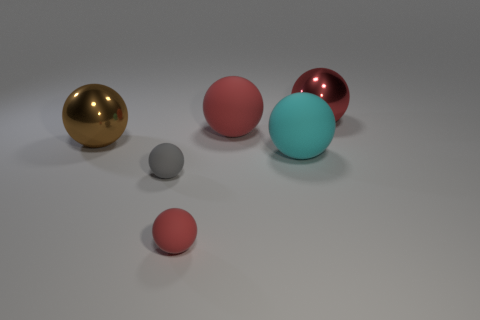How many red spheres must be subtracted to get 1 red spheres? 2 Add 2 yellow cubes. How many objects exist? 8 Subtract all red balls. How many balls are left? 3 Subtract all small gray rubber spheres. How many spheres are left? 5 Subtract 1 balls. How many balls are left? 5 Add 5 rubber spheres. How many rubber spheres exist? 9 Subtract 0 yellow cylinders. How many objects are left? 6 Subtract all cyan spheres. Subtract all red cubes. How many spheres are left? 5 Subtract all cyan blocks. How many gray spheres are left? 1 Subtract all large red shiny spheres. Subtract all cyan matte things. How many objects are left? 4 